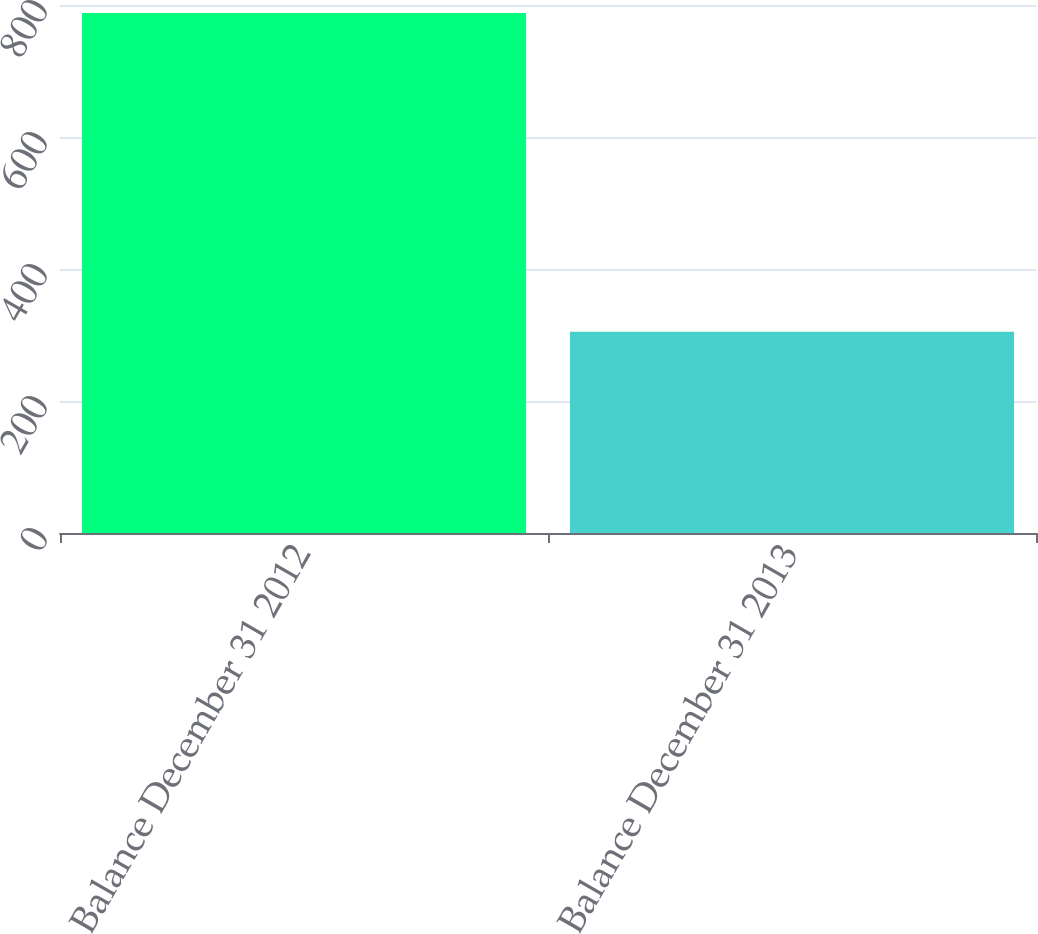Convert chart. <chart><loc_0><loc_0><loc_500><loc_500><bar_chart><fcel>Balance December 31 2012<fcel>Balance December 31 2013<nl><fcel>788<fcel>305<nl></chart> 